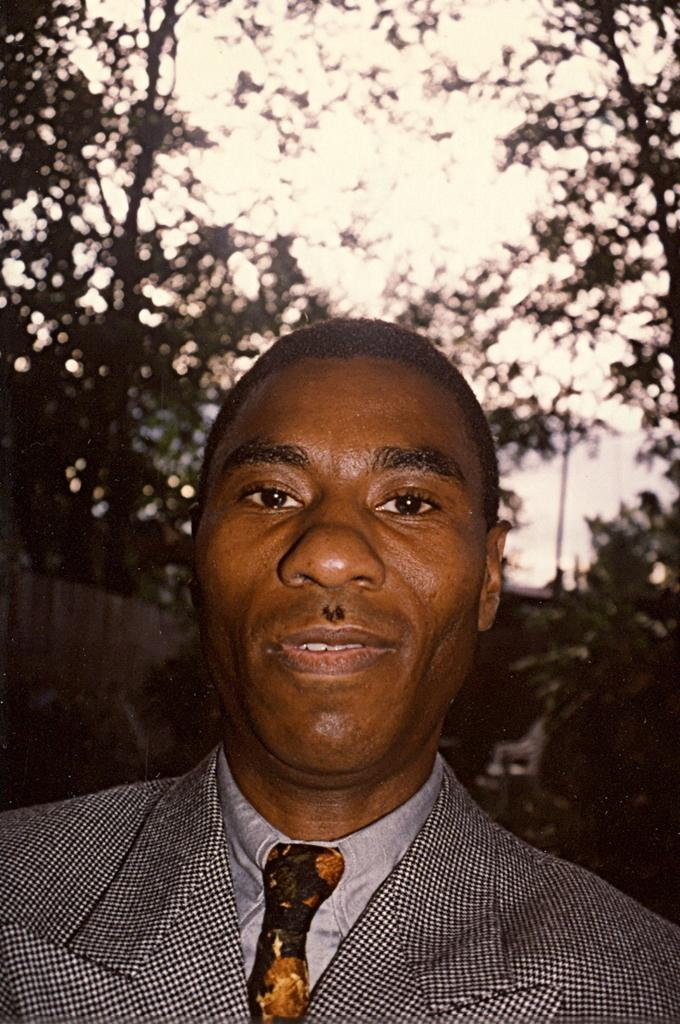Who is the main subject in the front of the image? There is a man in the front of the image. What type of natural scenery can be seen in the background of the image? There are trees in the background of the image. What is visible at the top of the image? The sky is visible at the top of the image. What company does the man represent in the image? There is no indication of a company or business in the image. How does the man turn around in the image? The man does not turn around in the image; he is facing forward. 